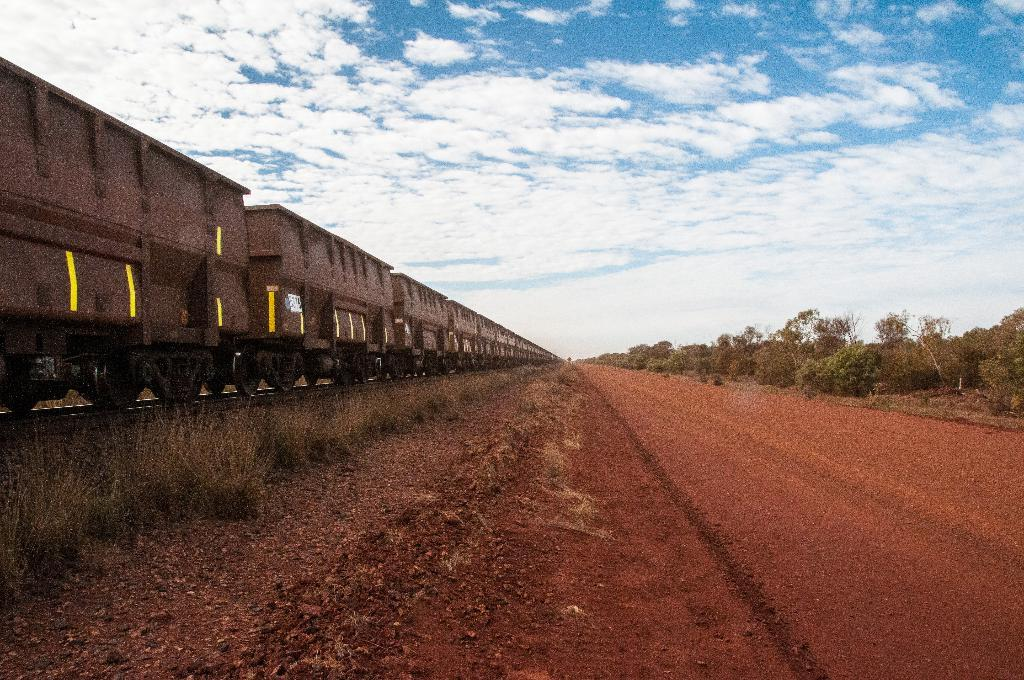What is the main feature of the image? There is a road in the image. What can be seen on the right side of the road? Trees are present to the right side of the road. What is located on the left side of the road? A brain is visible on the left side of the road. How would you describe the sky in the image? The sky is blue with clouds in the image. What type of prose can be seen written on the road in the image? There is no prose visible on the road in the image. What shape is the whip that is being used to control the brain in the image? There is no whip or any indication of controlling the brain in the image; it is simply a brain on the left side of the road. 